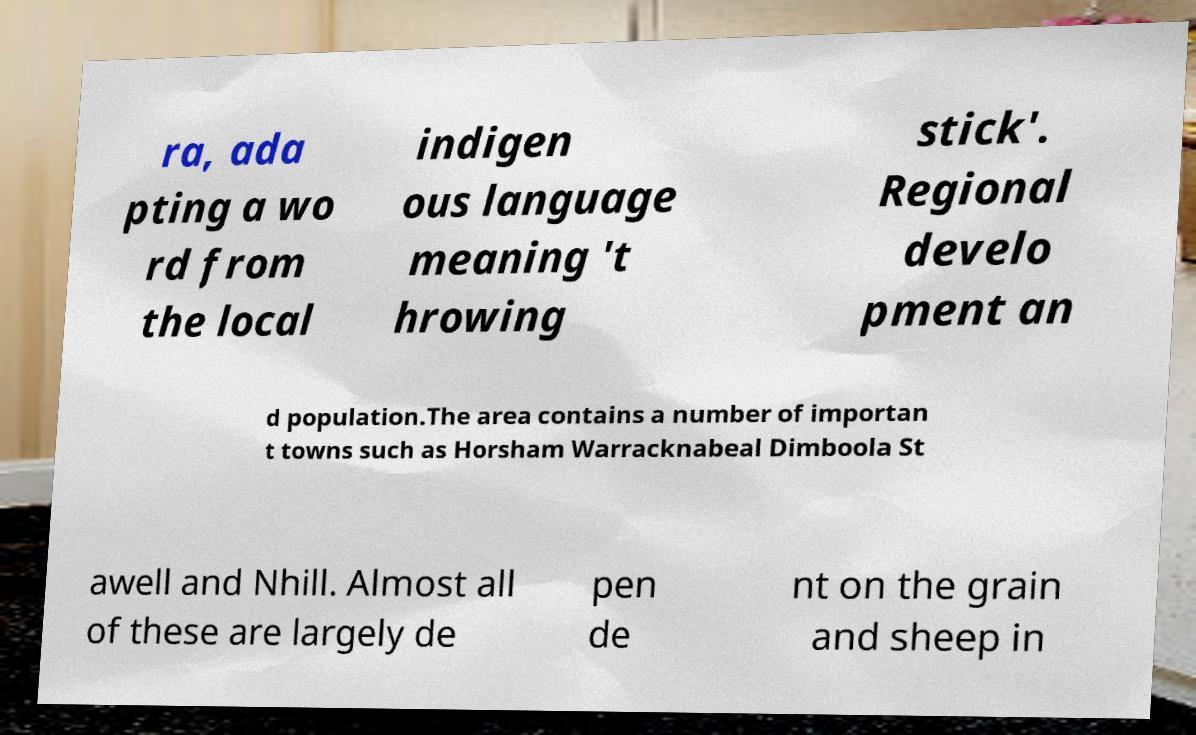Could you extract and type out the text from this image? ra, ada pting a wo rd from the local indigen ous language meaning 't hrowing stick'. Regional develo pment an d population.The area contains a number of importan t towns such as Horsham Warracknabeal Dimboola St awell and Nhill. Almost all of these are largely de pen de nt on the grain and sheep in 